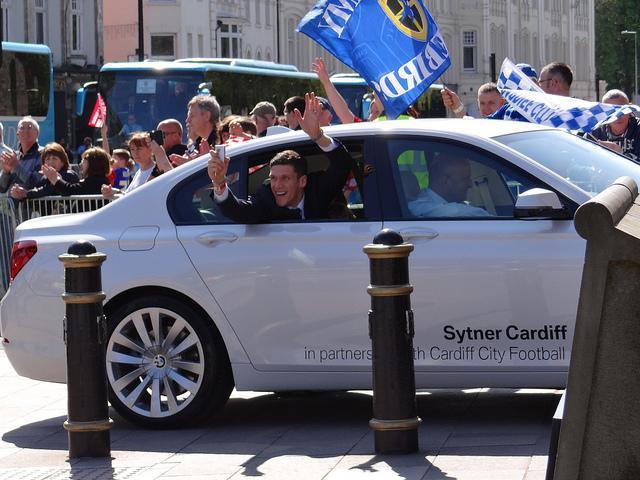How many people can you see?
Give a very brief answer. 4. How many buses are visible?
Give a very brief answer. 2. 